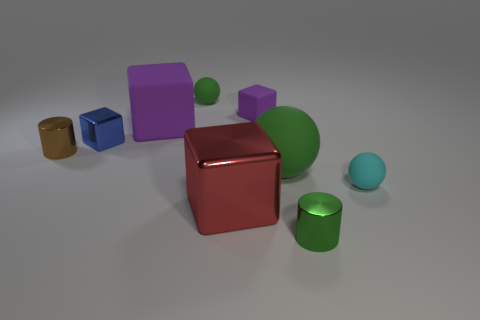Can you describe the relative positions of the purple block and the green sphere? Certainly! The purple block is located furthest to the left and towards the back of the image, while the largest green sphere is positioned more centrally and slightly closer to the foreground. 